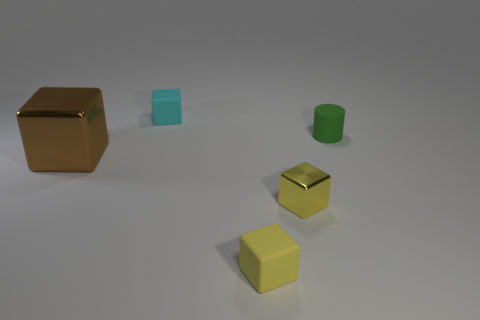Add 3 brown shiny cubes. How many objects exist? 8 Subtract all blocks. How many objects are left? 1 Add 2 small green matte spheres. How many small green matte spheres exist? 2 Subtract 0 blue cylinders. How many objects are left? 5 Subtract all large brown things. Subtract all tiny cyan matte blocks. How many objects are left? 3 Add 1 tiny cyan matte things. How many tiny cyan matte things are left? 2 